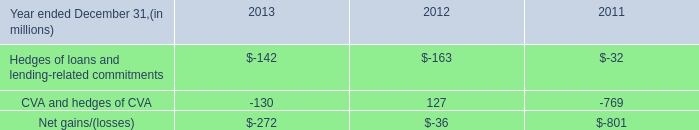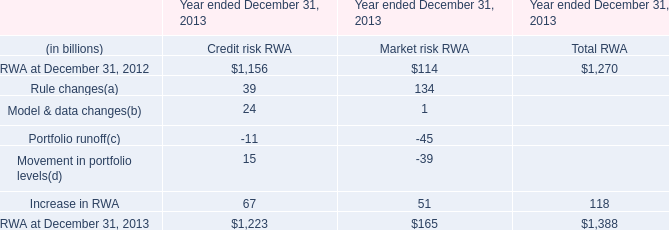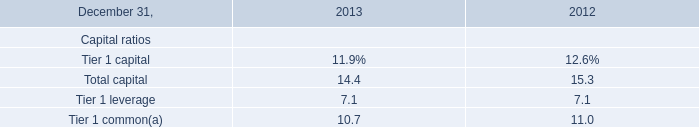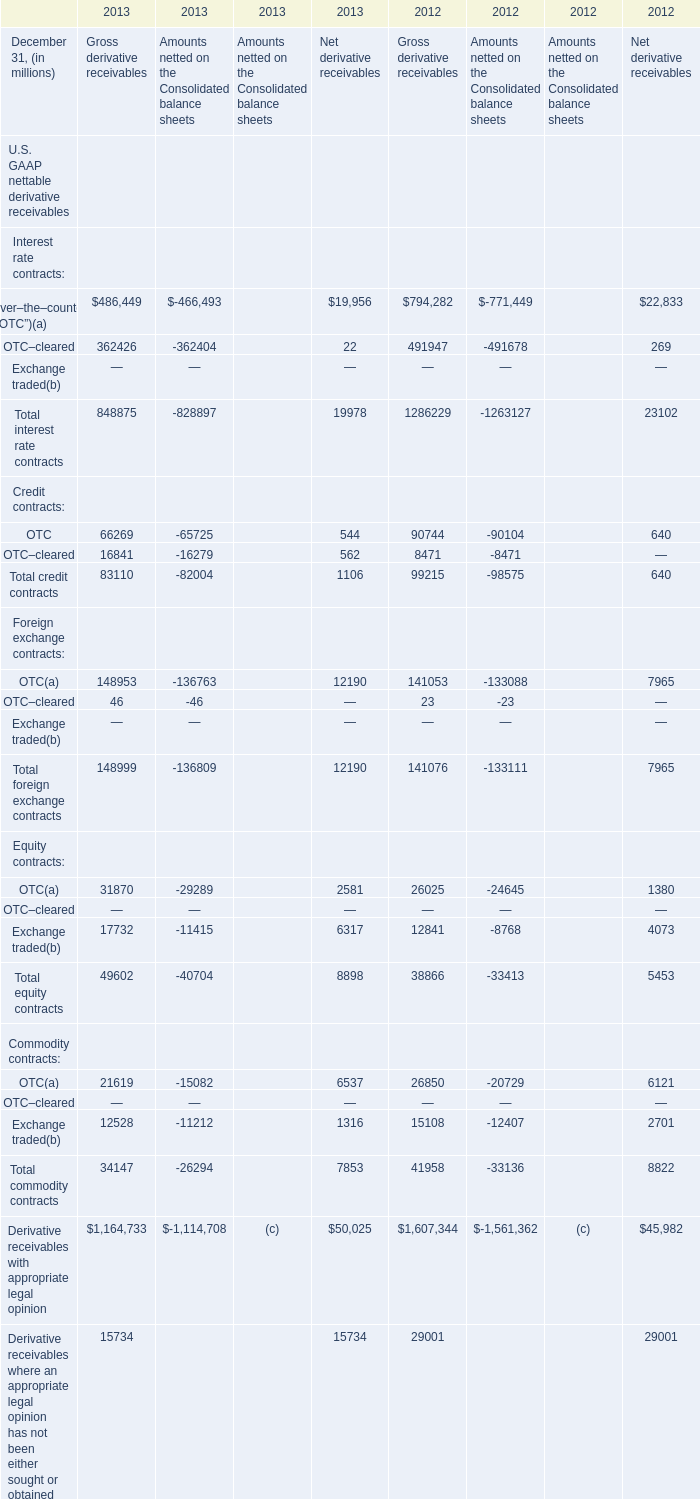Which year is Total credit contracts of Net derivative receivables the most? 
Answer: 2013. 